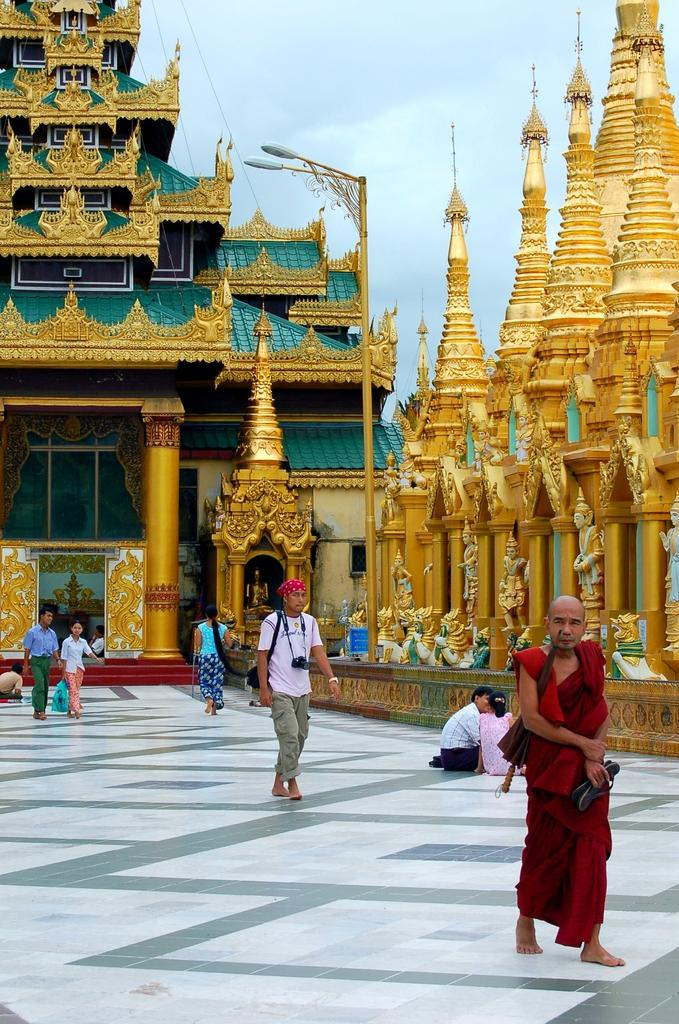What can be seen in the foreground of the image? There is a path in the image. What is happening in the background of the image? There are people walking in the background, and there is a Buddhist temple. What part of the natural environment is visible in the image? The sky is visible in the image. How many dolls are sitting on the head of the person walking in the image? There are no dolls present in the image, and no one is shown with dolls on their head. 